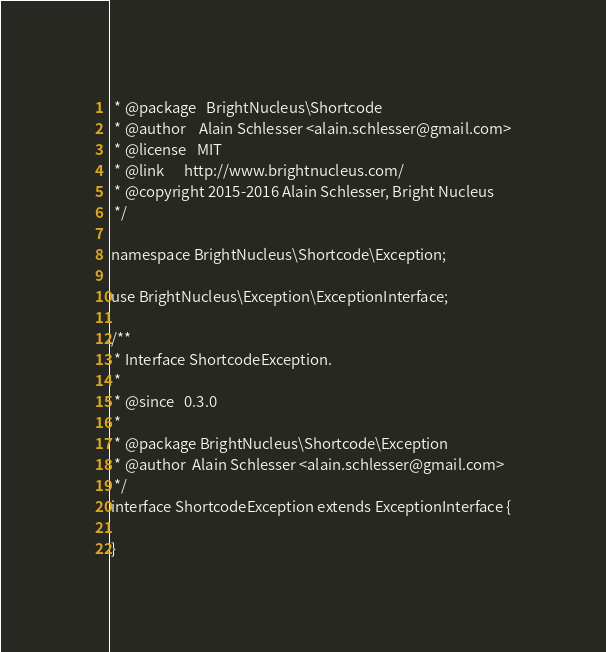Convert code to text. <code><loc_0><loc_0><loc_500><loc_500><_PHP_> * @package   BrightNucleus\Shortcode
 * @author    Alain Schlesser <alain.schlesser@gmail.com>
 * @license   MIT
 * @link      http://www.brightnucleus.com/
 * @copyright 2015-2016 Alain Schlesser, Bright Nucleus
 */

namespace BrightNucleus\Shortcode\Exception;

use BrightNucleus\Exception\ExceptionInterface;

/**
 * Interface ShortcodeException.
 *
 * @since   0.3.0
 *
 * @package BrightNucleus\Shortcode\Exception
 * @author  Alain Schlesser <alain.schlesser@gmail.com>
 */
interface ShortcodeException extends ExceptionInterface {

}
</code> 